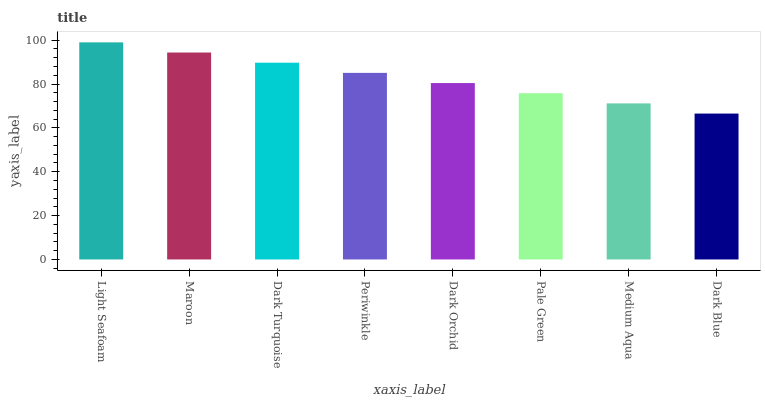Is Maroon the minimum?
Answer yes or no. No. Is Maroon the maximum?
Answer yes or no. No. Is Light Seafoam greater than Maroon?
Answer yes or no. Yes. Is Maroon less than Light Seafoam?
Answer yes or no. Yes. Is Maroon greater than Light Seafoam?
Answer yes or no. No. Is Light Seafoam less than Maroon?
Answer yes or no. No. Is Periwinkle the high median?
Answer yes or no. Yes. Is Dark Orchid the low median?
Answer yes or no. Yes. Is Medium Aqua the high median?
Answer yes or no. No. Is Dark Blue the low median?
Answer yes or no. No. 